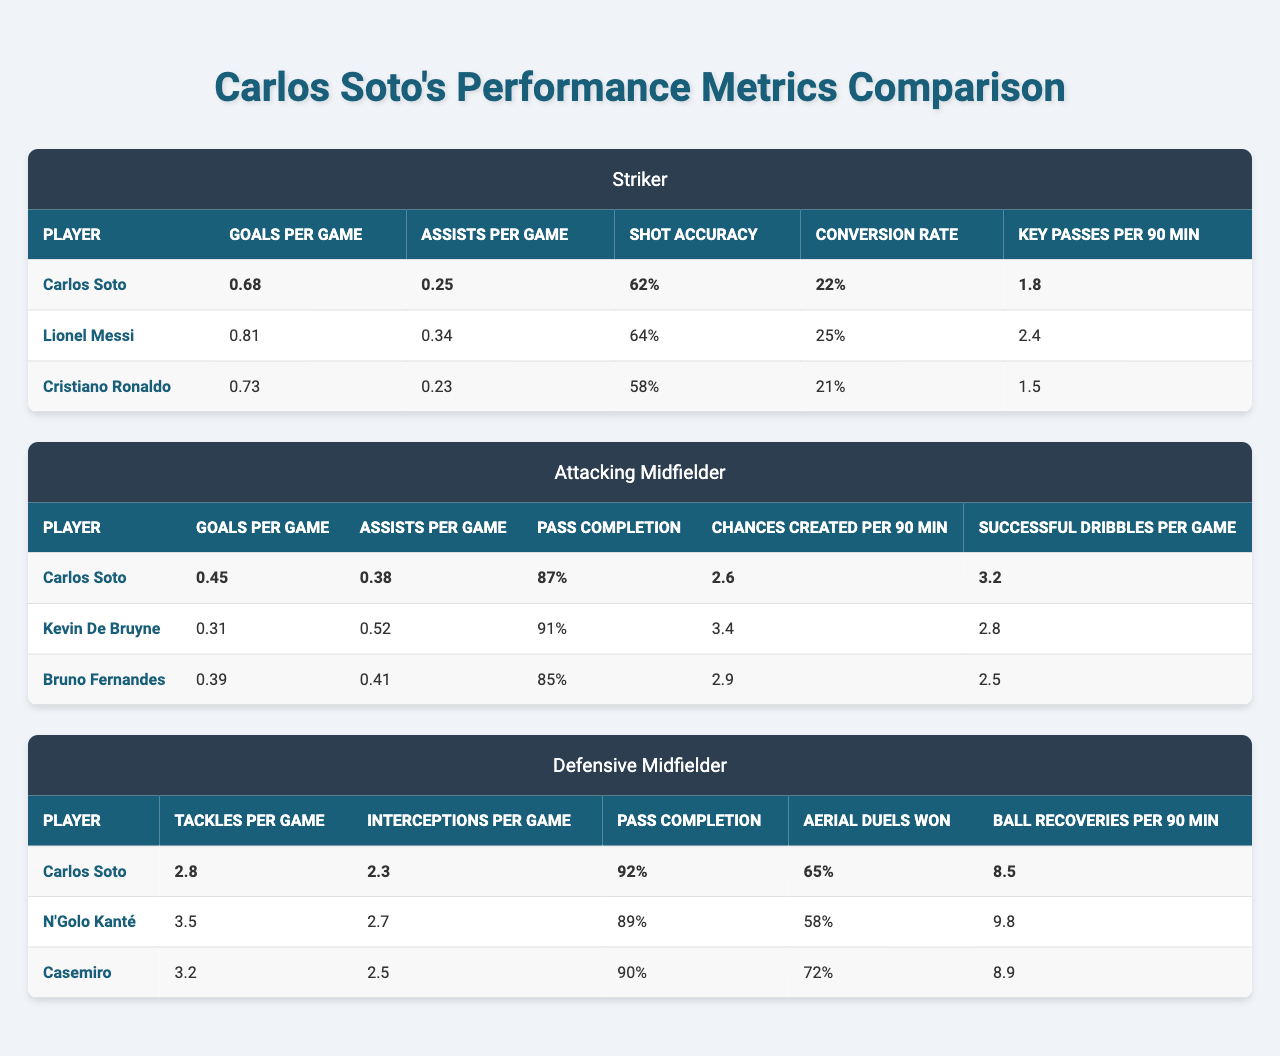What is the goal per game metric for Carlos Soto as a striker? The table shows that Carlos Soto's "Goals per Game" for the striker position is listed as 0.68.
Answer: 0.68 How does Carlos Soto's shot accuracy compare to Lionel Messi's? Carlos Soto's shot accuracy is 62%, while Lionel Messi's shot accuracy is 64%. Messi has a slightly higher shot accuracy than Soto.
Answer: Messi has a higher shot accuracy Which player has the highest assists per game as an attacking midfielder? Looking at the attacking midfielder section, Kevin De Bruyne has the highest "Assists per Game" at 0.52, compared to Carlos Soto (0.38) and Bruno Fernandes (0.41).
Answer: Kevin De Bruyne What is the average goals per game of the three strikers compared? To find the average goals per game for the strikers, sum their goals: (0.68 + 0.81 + 0.73) = 2.22 and then divide by 3, which gives 2.22/3 = 0.74.
Answer: 0.74 How many more key passes per 90 minutes does Lionel Messi have compared to Carlos Soto as a striker? Lionel Messi has 2.4 key passes per 90 minutes, while Carlos Soto has 1.8. The difference is 2.4 - 1.8 = 0.6.
Answer: 0.6 Is Carlos Soto's pass completion rate as a defensive midfielder higher than N'Golo Kanté's? Carlos Soto has a "Pass Completion" of 92%, while N'Golo Kanté has a rate of 89%. Therefore, Soto's rate is higher.
Answer: Yes What is the difference in tackles per game between Carlos Soto and Casemiro? Carlos Soto averages 2.8 tackles per game, while Casemiro averages 3.2. The difference is 3.2 - 2.8 = 0.4.
Answer: 0.4 How many total assists do Carlos Soto, Kevin De Bruyne, and Bruno Fernandes have when added together as attacking midfielders? Their assists add up as follows: 0.38 (Soto) + 0.31 (De Bruyne) + 0.39 (Fernandes) = 1.08 assists total.
Answer: 1.08 Which player created the most chances per 90 minutes among the attacking midfielders? By reviewing the "Chances Created per 90 min" metric, Kevin De Bruyne has the highest at 3.4 compared to Soto (2.6) and Fernandes (2.9).
Answer: Kevin De Bruyne Overall, who has the highest conversion rate among the strikers? The table shows that Lionel Messi has the highest conversion rate at 25%, followed by Carlos Soto (22%) and Cristiano Ronaldo (21%).
Answer: Lionel Messi 